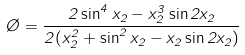<formula> <loc_0><loc_0><loc_500><loc_500>\chi = \frac { 2 \sin ^ { 4 } x _ { 2 } - x _ { 2 } ^ { 3 } \sin 2 x _ { 2 } } { 2 ( x _ { 2 } ^ { 2 } + \sin ^ { 2 } x _ { 2 } - x _ { 2 } \sin 2 x _ { 2 } ) }</formula> 